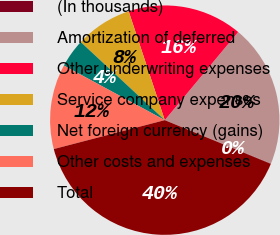Convert chart. <chart><loc_0><loc_0><loc_500><loc_500><pie_chart><fcel>(In thousands)<fcel>Amortization of deferred<fcel>Other underwriting expenses<fcel>Service company expenses<fcel>Net foreign currency (gains)<fcel>Other costs and expenses<fcel>Total<nl><fcel>0.05%<fcel>20.12%<fcel>16.15%<fcel>7.99%<fcel>4.02%<fcel>11.95%<fcel>39.72%<nl></chart> 